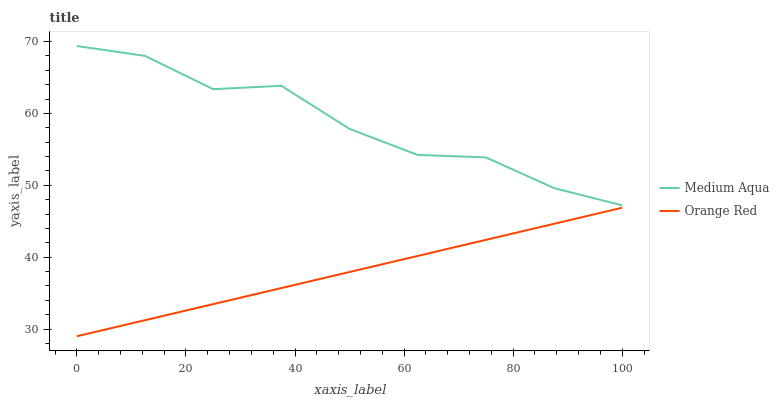Does Orange Red have the minimum area under the curve?
Answer yes or no. Yes. Does Medium Aqua have the maximum area under the curve?
Answer yes or no. Yes. Does Orange Red have the maximum area under the curve?
Answer yes or no. No. Is Orange Red the smoothest?
Answer yes or no. Yes. Is Medium Aqua the roughest?
Answer yes or no. Yes. Is Orange Red the roughest?
Answer yes or no. No. Does Orange Red have the lowest value?
Answer yes or no. Yes. Does Medium Aqua have the highest value?
Answer yes or no. Yes. Does Orange Red have the highest value?
Answer yes or no. No. Is Orange Red less than Medium Aqua?
Answer yes or no. Yes. Is Medium Aqua greater than Orange Red?
Answer yes or no. Yes. Does Orange Red intersect Medium Aqua?
Answer yes or no. No. 